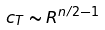Convert formula to latex. <formula><loc_0><loc_0><loc_500><loc_500>c _ { T } \sim R ^ { n / 2 - 1 }</formula> 